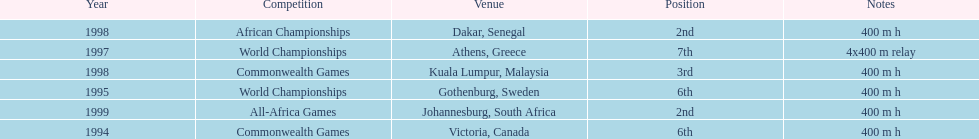In what year did ken harnden participate in more than one competition? 1998. 